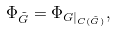Convert formula to latex. <formula><loc_0><loc_0><loc_500><loc_500>\Phi _ { \tilde { G } } = \Phi _ { G | _ { C ( \tilde { G } ) } } ,</formula> 